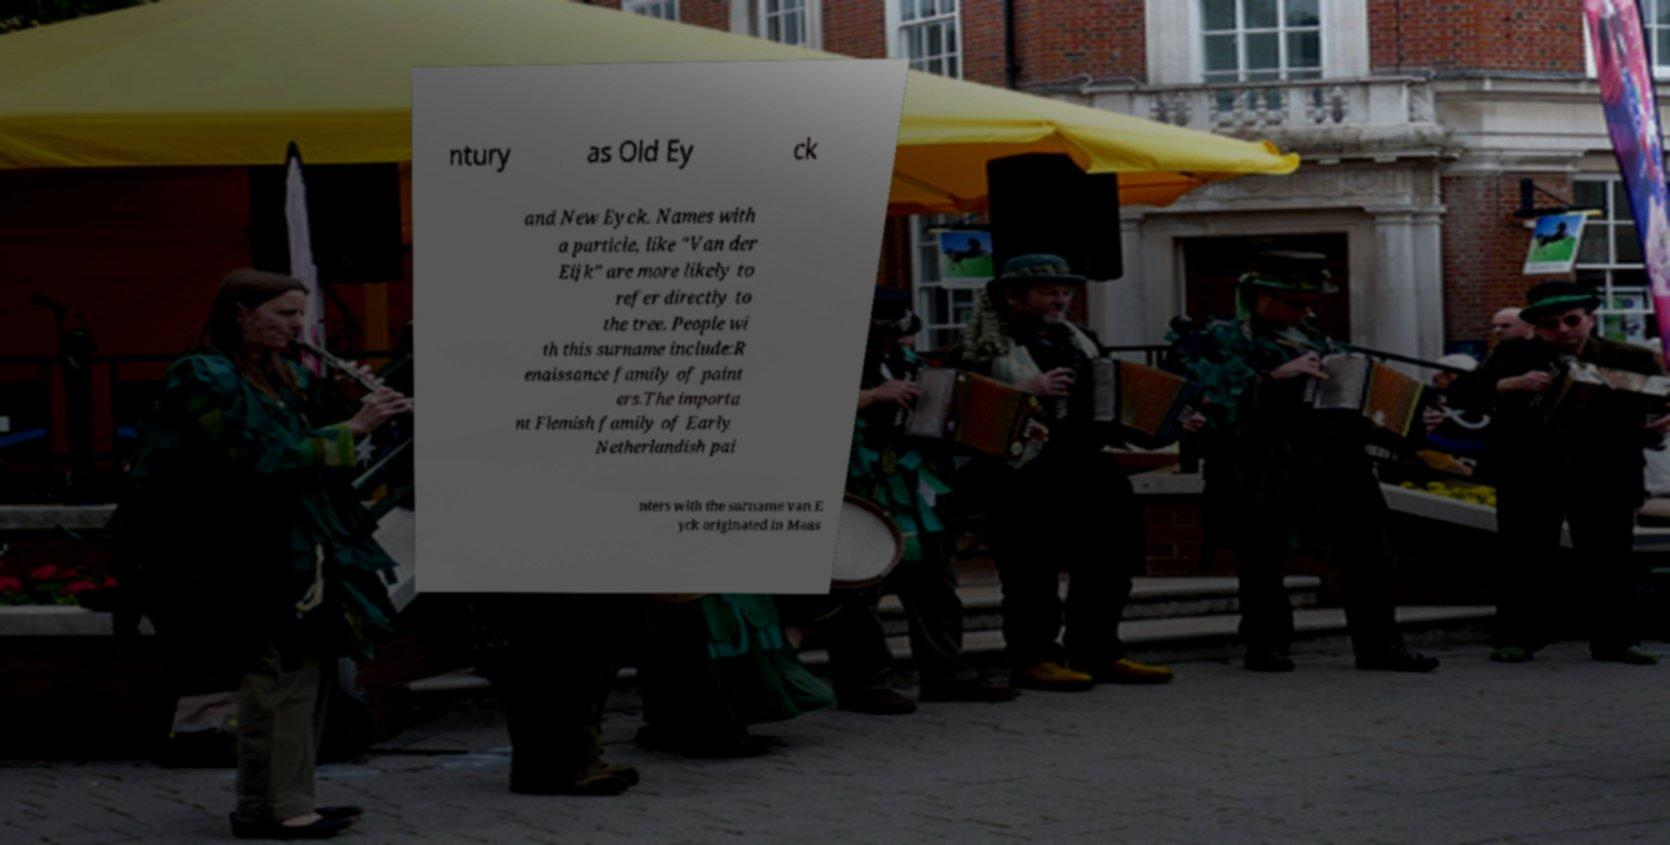Please read and relay the text visible in this image. What does it say? ntury as Old Ey ck and New Eyck. Names with a particle, like "Van der Eijk" are more likely to refer directly to the tree. People wi th this surname include:R enaissance family of paint ers.The importa nt Flemish family of Early Netherlandish pai nters with the surname van E yck originated in Maas 